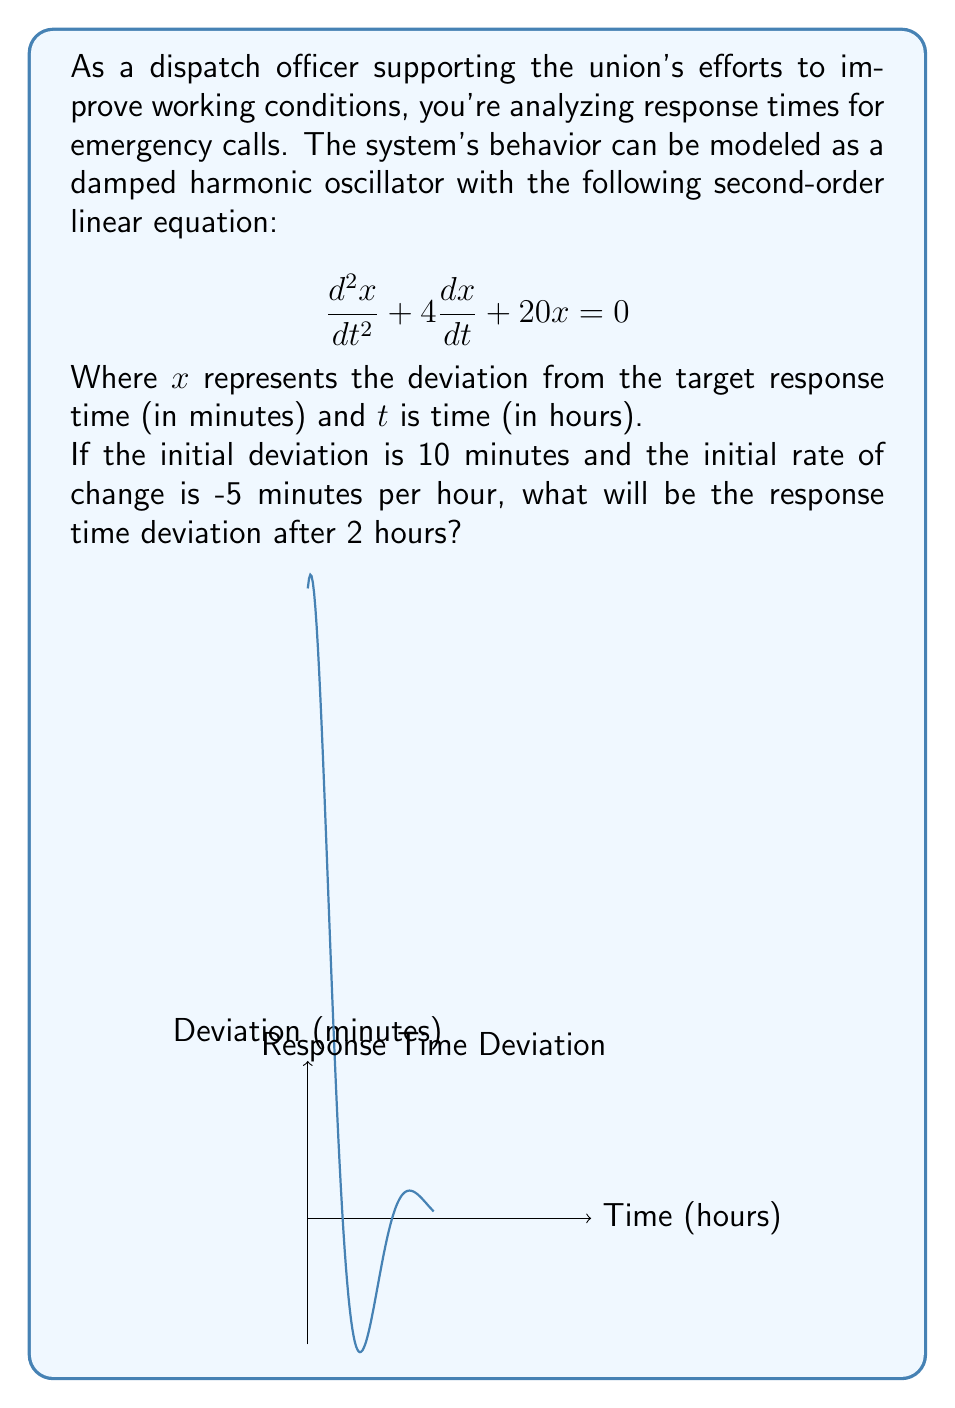Could you help me with this problem? Let's solve this step-by-step:

1) The general solution for this damped harmonic oscillator is:
   $$x(t) = e^{-2t}(A\cos(4t) + B\sin(4t))$$

2) We need to find A and B using the initial conditions:
   At $t=0$, $x(0) = 10$ and $\frac{dx}{dt}(0) = -5$

3) From $x(0) = 10$:
   $$10 = A$$

4) From $\frac{dx}{dt}(0) = -5$:
   $$\frac{dx}{dt} = e^{-2t}(-2A\cos(4t) - 2B\sin(4t) - 4A\sin(4t) + 4B\cos(4t))$$
   $$-5 = -2A + 4B$$
   $$-5 = -20 + 4B$$
   $$15 = 4B$$
   $$B = \frac{15}{4} = 3.75$$

5) Therefore, the solution is:
   $$x(t) = e^{-2t}(10\cos(4t) + 3.75\sin(4t))$$

6) To find the deviation after 2 hours, we substitute $t=2$:
   $$x(2) = e^{-4}(10\cos(8) + 3.75\sin(8))$$

7) Calculating this:
   $$x(2) \approx 0.0183\text{ minutes} \approx 1.1\text{ seconds}$$
Answer: 1.1 seconds 